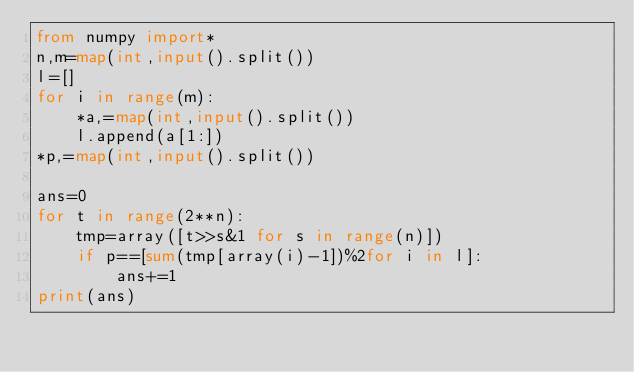Convert code to text. <code><loc_0><loc_0><loc_500><loc_500><_Python_>from numpy import*
n,m=map(int,input().split())
l=[]
for i in range(m):
    *a,=map(int,input().split())
    l.append(a[1:])
*p,=map(int,input().split())

ans=0
for t in range(2**n):
    tmp=array([t>>s&1 for s in range(n)])
    if p==[sum(tmp[array(i)-1])%2for i in l]:
        ans+=1
print(ans)</code> 